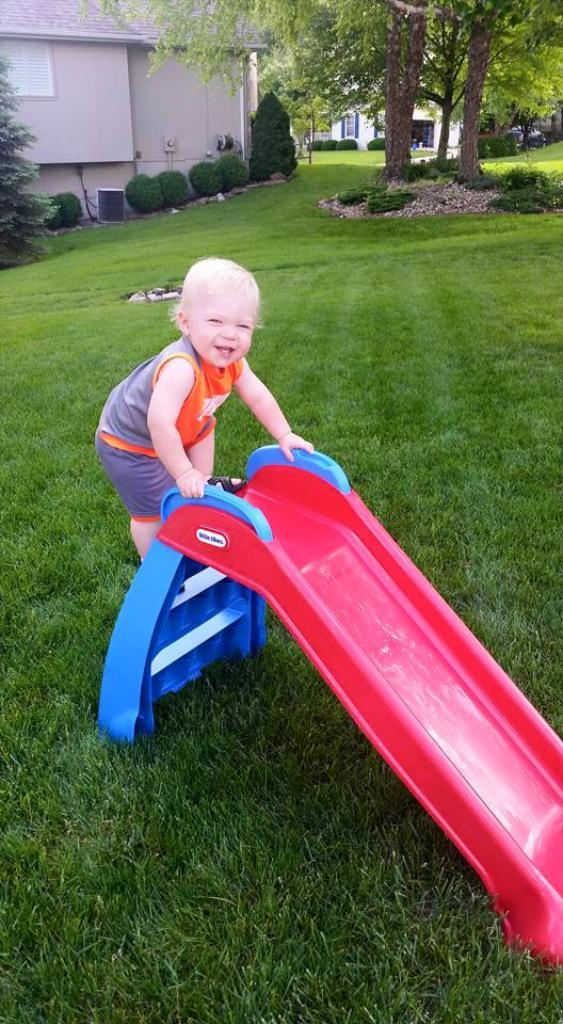What is the main subject in the foreground of the image? There is a kid in the foreground of the image. What is the kid doing in the image? The kid is climbing on a slide. Where is the slide located? The slide is on the grass. What can be seen in the background of the image? There are buildings, trees, shrubs, and grass in the background of the image. What is the title of the book the kid is reading on the slide? There is no book present in the image, and the kid is not reading anything while climbing on the slide. 